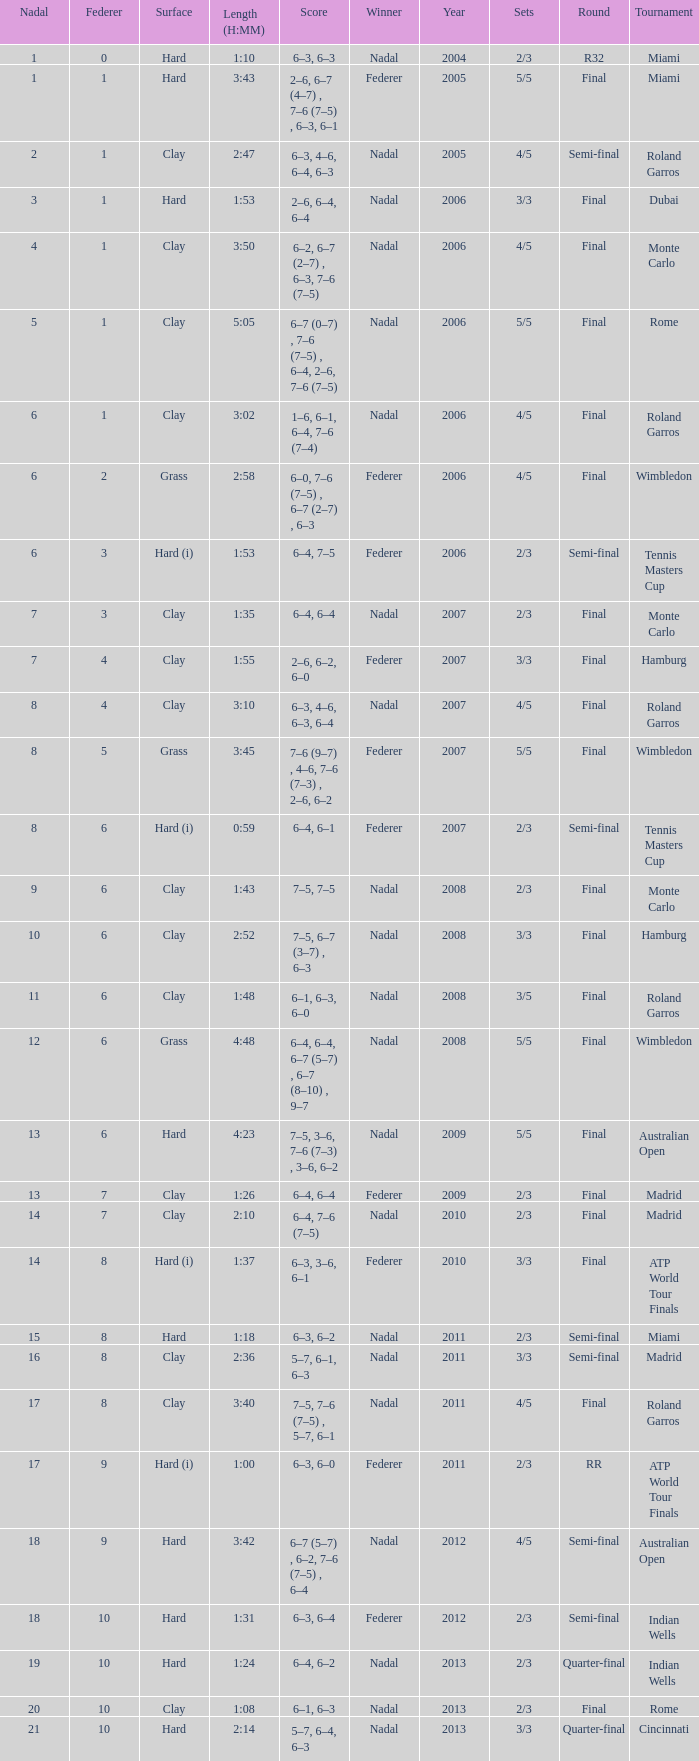What were the sets when Federer had 6 and a nadal of 13? 5/5. 